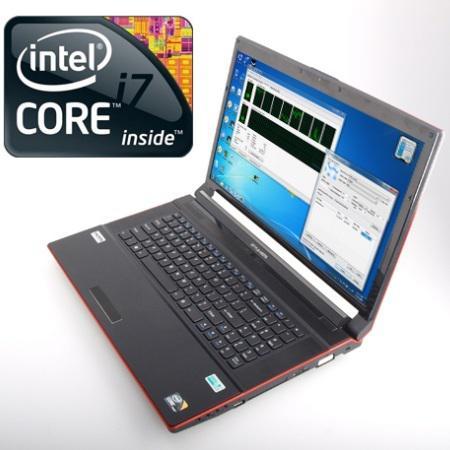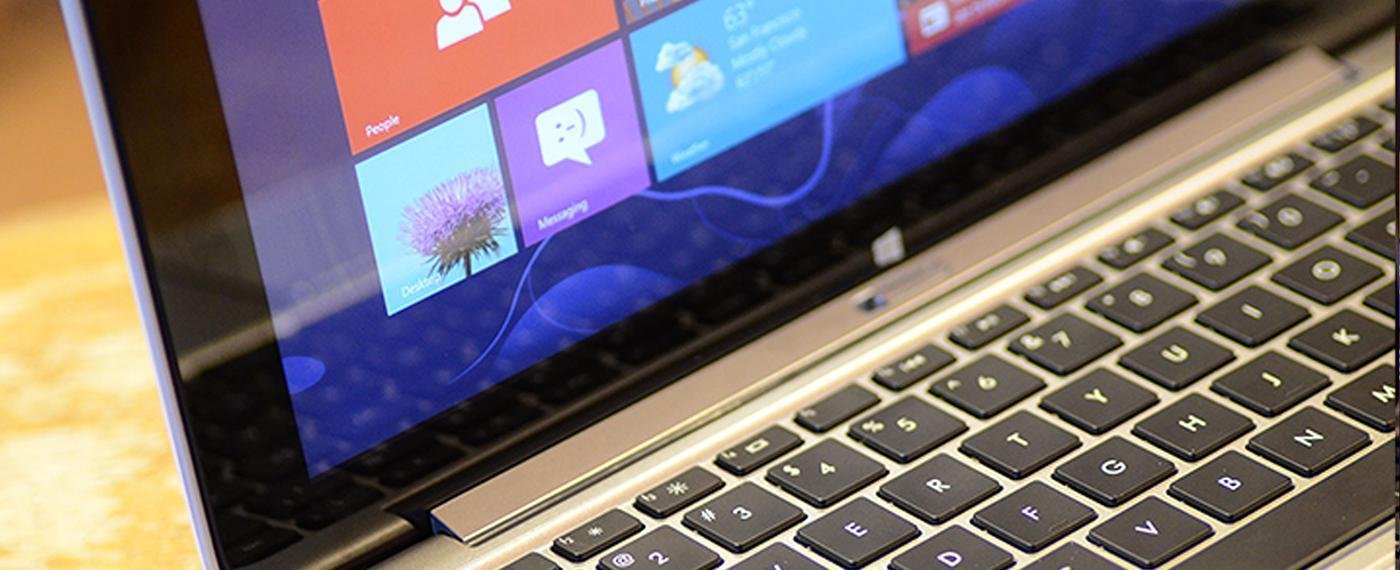The first image is the image on the left, the second image is the image on the right. Analyze the images presented: Is the assertion "One image includes a phone resting on a keyboard and near a device with a larger screen rimmed in white." valid? Answer yes or no. No. The first image is the image on the left, the second image is the image on the right. Evaluate the accuracy of this statement regarding the images: "A smartphone and a tablet are laying on top of a laptop keyboard.". Is it true? Answer yes or no. No. 